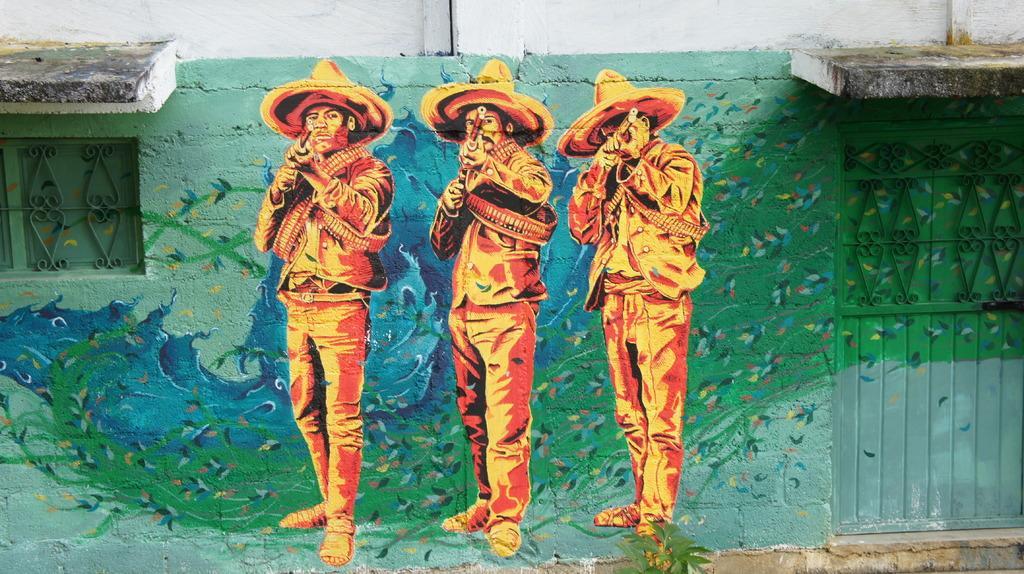How would you summarize this image in a sentence or two? In this image we can see a painting on the wall. There is a door on the right side of the image. On the left side of the image, we can see a window. 